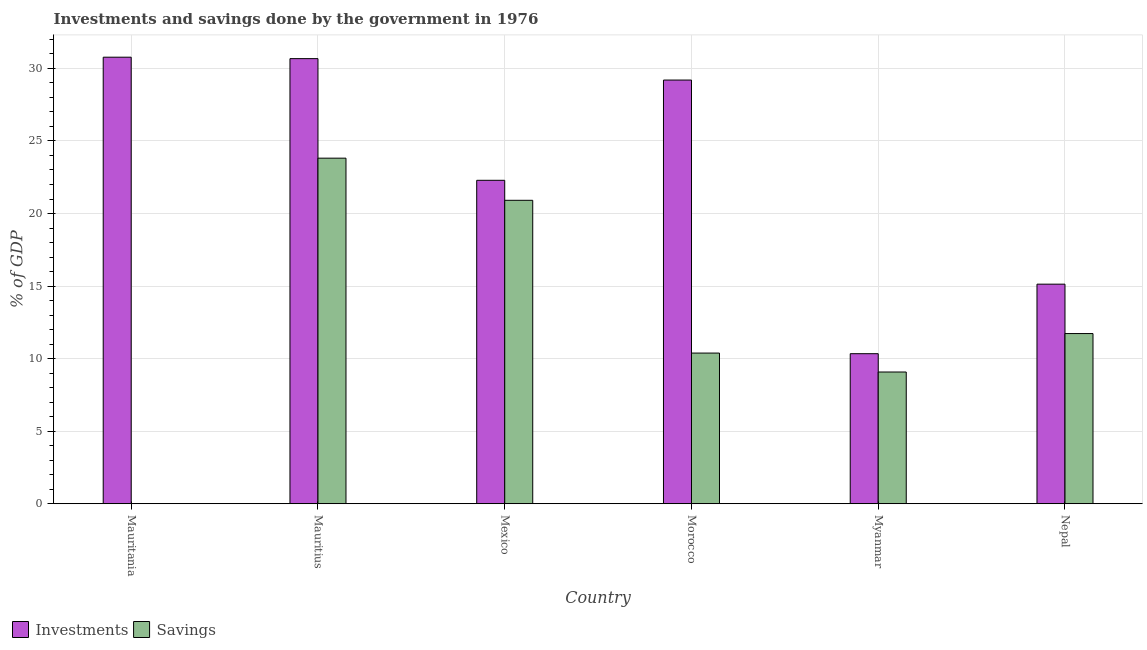Are the number of bars per tick equal to the number of legend labels?
Your response must be concise. No. How many bars are there on the 4th tick from the left?
Your answer should be compact. 2. How many bars are there on the 6th tick from the right?
Make the answer very short. 1. What is the label of the 2nd group of bars from the left?
Your answer should be compact. Mauritius. What is the investments of government in Nepal?
Your answer should be compact. 15.13. Across all countries, what is the maximum investments of government?
Offer a very short reply. 30.77. Across all countries, what is the minimum investments of government?
Offer a terse response. 10.34. In which country was the investments of government maximum?
Ensure brevity in your answer.  Mauritania. What is the total savings of government in the graph?
Your response must be concise. 75.92. What is the difference between the savings of government in Mauritius and that in Mexico?
Provide a succinct answer. 2.9. What is the difference between the investments of government in Myanmar and the savings of government in Morocco?
Ensure brevity in your answer.  -0.04. What is the average savings of government per country?
Give a very brief answer. 12.65. What is the difference between the savings of government and investments of government in Mexico?
Ensure brevity in your answer.  -1.38. In how many countries, is the investments of government greater than 31 %?
Give a very brief answer. 0. What is the ratio of the investments of government in Mauritania to that in Mauritius?
Offer a terse response. 1. Is the investments of government in Mexico less than that in Myanmar?
Make the answer very short. No. Is the difference between the investments of government in Mauritius and Nepal greater than the difference between the savings of government in Mauritius and Nepal?
Provide a short and direct response. Yes. What is the difference between the highest and the second highest investments of government?
Offer a very short reply. 0.1. What is the difference between the highest and the lowest investments of government?
Keep it short and to the point. 20.43. How many bars are there?
Keep it short and to the point. 11. How many countries are there in the graph?
Your answer should be compact. 6. What is the difference between two consecutive major ticks on the Y-axis?
Provide a succinct answer. 5. Are the values on the major ticks of Y-axis written in scientific E-notation?
Give a very brief answer. No. Does the graph contain any zero values?
Offer a terse response. Yes. Does the graph contain grids?
Your answer should be very brief. Yes. Where does the legend appear in the graph?
Provide a short and direct response. Bottom left. How many legend labels are there?
Your answer should be compact. 2. How are the legend labels stacked?
Offer a terse response. Horizontal. What is the title of the graph?
Provide a succinct answer. Investments and savings done by the government in 1976. What is the label or title of the X-axis?
Your answer should be compact. Country. What is the label or title of the Y-axis?
Give a very brief answer. % of GDP. What is the % of GDP in Investments in Mauritania?
Give a very brief answer. 30.77. What is the % of GDP in Investments in Mauritius?
Keep it short and to the point. 30.67. What is the % of GDP in Savings in Mauritius?
Make the answer very short. 23.82. What is the % of GDP in Investments in Mexico?
Make the answer very short. 22.29. What is the % of GDP in Savings in Mexico?
Keep it short and to the point. 20.91. What is the % of GDP of Investments in Morocco?
Offer a terse response. 29.2. What is the % of GDP in Savings in Morocco?
Offer a terse response. 10.38. What is the % of GDP of Investments in Myanmar?
Provide a succinct answer. 10.34. What is the % of GDP in Savings in Myanmar?
Your response must be concise. 9.08. What is the % of GDP in Investments in Nepal?
Ensure brevity in your answer.  15.13. What is the % of GDP of Savings in Nepal?
Your answer should be compact. 11.73. Across all countries, what is the maximum % of GDP in Investments?
Provide a succinct answer. 30.77. Across all countries, what is the maximum % of GDP in Savings?
Your response must be concise. 23.82. Across all countries, what is the minimum % of GDP of Investments?
Your answer should be compact. 10.34. What is the total % of GDP of Investments in the graph?
Ensure brevity in your answer.  138.41. What is the total % of GDP in Savings in the graph?
Offer a very short reply. 75.92. What is the difference between the % of GDP in Investments in Mauritania and that in Mauritius?
Provide a succinct answer. 0.1. What is the difference between the % of GDP in Investments in Mauritania and that in Mexico?
Keep it short and to the point. 8.48. What is the difference between the % of GDP of Investments in Mauritania and that in Morocco?
Keep it short and to the point. 1.58. What is the difference between the % of GDP in Investments in Mauritania and that in Myanmar?
Offer a very short reply. 20.43. What is the difference between the % of GDP in Investments in Mauritania and that in Nepal?
Ensure brevity in your answer.  15.64. What is the difference between the % of GDP of Investments in Mauritius and that in Mexico?
Your answer should be compact. 8.39. What is the difference between the % of GDP of Savings in Mauritius and that in Mexico?
Offer a very short reply. 2.9. What is the difference between the % of GDP of Investments in Mauritius and that in Morocco?
Your answer should be very brief. 1.48. What is the difference between the % of GDP in Savings in Mauritius and that in Morocco?
Make the answer very short. 13.43. What is the difference between the % of GDP of Investments in Mauritius and that in Myanmar?
Make the answer very short. 20.33. What is the difference between the % of GDP of Savings in Mauritius and that in Myanmar?
Keep it short and to the point. 14.74. What is the difference between the % of GDP of Investments in Mauritius and that in Nepal?
Ensure brevity in your answer.  15.54. What is the difference between the % of GDP of Savings in Mauritius and that in Nepal?
Provide a short and direct response. 12.09. What is the difference between the % of GDP of Investments in Mexico and that in Morocco?
Offer a very short reply. -6.91. What is the difference between the % of GDP in Savings in Mexico and that in Morocco?
Offer a very short reply. 10.53. What is the difference between the % of GDP in Investments in Mexico and that in Myanmar?
Offer a terse response. 11.95. What is the difference between the % of GDP in Savings in Mexico and that in Myanmar?
Give a very brief answer. 11.83. What is the difference between the % of GDP of Investments in Mexico and that in Nepal?
Your answer should be compact. 7.16. What is the difference between the % of GDP of Savings in Mexico and that in Nepal?
Ensure brevity in your answer.  9.18. What is the difference between the % of GDP of Investments in Morocco and that in Myanmar?
Offer a terse response. 18.86. What is the difference between the % of GDP of Savings in Morocco and that in Myanmar?
Keep it short and to the point. 1.3. What is the difference between the % of GDP in Investments in Morocco and that in Nepal?
Give a very brief answer. 14.07. What is the difference between the % of GDP of Savings in Morocco and that in Nepal?
Your response must be concise. -1.34. What is the difference between the % of GDP of Investments in Myanmar and that in Nepal?
Provide a short and direct response. -4.79. What is the difference between the % of GDP in Savings in Myanmar and that in Nepal?
Your answer should be very brief. -2.65. What is the difference between the % of GDP in Investments in Mauritania and the % of GDP in Savings in Mauritius?
Offer a terse response. 6.96. What is the difference between the % of GDP in Investments in Mauritania and the % of GDP in Savings in Mexico?
Provide a succinct answer. 9.86. What is the difference between the % of GDP in Investments in Mauritania and the % of GDP in Savings in Morocco?
Provide a succinct answer. 20.39. What is the difference between the % of GDP in Investments in Mauritania and the % of GDP in Savings in Myanmar?
Give a very brief answer. 21.69. What is the difference between the % of GDP of Investments in Mauritania and the % of GDP of Savings in Nepal?
Provide a succinct answer. 19.04. What is the difference between the % of GDP of Investments in Mauritius and the % of GDP of Savings in Mexico?
Give a very brief answer. 9.76. What is the difference between the % of GDP in Investments in Mauritius and the % of GDP in Savings in Morocco?
Provide a succinct answer. 20.29. What is the difference between the % of GDP in Investments in Mauritius and the % of GDP in Savings in Myanmar?
Your answer should be very brief. 21.6. What is the difference between the % of GDP in Investments in Mauritius and the % of GDP in Savings in Nepal?
Offer a very short reply. 18.95. What is the difference between the % of GDP of Investments in Mexico and the % of GDP of Savings in Morocco?
Your response must be concise. 11.91. What is the difference between the % of GDP in Investments in Mexico and the % of GDP in Savings in Myanmar?
Your answer should be compact. 13.21. What is the difference between the % of GDP in Investments in Mexico and the % of GDP in Savings in Nepal?
Provide a short and direct response. 10.56. What is the difference between the % of GDP of Investments in Morocco and the % of GDP of Savings in Myanmar?
Keep it short and to the point. 20.12. What is the difference between the % of GDP in Investments in Morocco and the % of GDP in Savings in Nepal?
Provide a succinct answer. 17.47. What is the difference between the % of GDP of Investments in Myanmar and the % of GDP of Savings in Nepal?
Keep it short and to the point. -1.39. What is the average % of GDP of Investments per country?
Ensure brevity in your answer.  23.07. What is the average % of GDP in Savings per country?
Ensure brevity in your answer.  12.65. What is the difference between the % of GDP in Investments and % of GDP in Savings in Mauritius?
Provide a short and direct response. 6.86. What is the difference between the % of GDP in Investments and % of GDP in Savings in Mexico?
Your response must be concise. 1.38. What is the difference between the % of GDP of Investments and % of GDP of Savings in Morocco?
Give a very brief answer. 18.81. What is the difference between the % of GDP in Investments and % of GDP in Savings in Myanmar?
Offer a terse response. 1.26. What is the difference between the % of GDP in Investments and % of GDP in Savings in Nepal?
Your answer should be compact. 3.4. What is the ratio of the % of GDP of Investments in Mauritania to that in Mauritius?
Keep it short and to the point. 1. What is the ratio of the % of GDP in Investments in Mauritania to that in Mexico?
Provide a succinct answer. 1.38. What is the ratio of the % of GDP of Investments in Mauritania to that in Morocco?
Provide a succinct answer. 1.05. What is the ratio of the % of GDP of Investments in Mauritania to that in Myanmar?
Your answer should be very brief. 2.98. What is the ratio of the % of GDP in Investments in Mauritania to that in Nepal?
Make the answer very short. 2.03. What is the ratio of the % of GDP in Investments in Mauritius to that in Mexico?
Make the answer very short. 1.38. What is the ratio of the % of GDP of Savings in Mauritius to that in Mexico?
Offer a terse response. 1.14. What is the ratio of the % of GDP in Investments in Mauritius to that in Morocco?
Your answer should be very brief. 1.05. What is the ratio of the % of GDP in Savings in Mauritius to that in Morocco?
Make the answer very short. 2.29. What is the ratio of the % of GDP of Investments in Mauritius to that in Myanmar?
Make the answer very short. 2.97. What is the ratio of the % of GDP of Savings in Mauritius to that in Myanmar?
Ensure brevity in your answer.  2.62. What is the ratio of the % of GDP of Investments in Mauritius to that in Nepal?
Provide a succinct answer. 2.03. What is the ratio of the % of GDP in Savings in Mauritius to that in Nepal?
Offer a terse response. 2.03. What is the ratio of the % of GDP of Investments in Mexico to that in Morocco?
Make the answer very short. 0.76. What is the ratio of the % of GDP in Savings in Mexico to that in Morocco?
Ensure brevity in your answer.  2.01. What is the ratio of the % of GDP of Investments in Mexico to that in Myanmar?
Your answer should be very brief. 2.16. What is the ratio of the % of GDP in Savings in Mexico to that in Myanmar?
Keep it short and to the point. 2.3. What is the ratio of the % of GDP of Investments in Mexico to that in Nepal?
Offer a terse response. 1.47. What is the ratio of the % of GDP in Savings in Mexico to that in Nepal?
Provide a short and direct response. 1.78. What is the ratio of the % of GDP of Investments in Morocco to that in Myanmar?
Your response must be concise. 2.82. What is the ratio of the % of GDP in Savings in Morocco to that in Myanmar?
Make the answer very short. 1.14. What is the ratio of the % of GDP in Investments in Morocco to that in Nepal?
Your answer should be compact. 1.93. What is the ratio of the % of GDP in Savings in Morocco to that in Nepal?
Offer a very short reply. 0.89. What is the ratio of the % of GDP of Investments in Myanmar to that in Nepal?
Your answer should be very brief. 0.68. What is the ratio of the % of GDP of Savings in Myanmar to that in Nepal?
Ensure brevity in your answer.  0.77. What is the difference between the highest and the second highest % of GDP in Investments?
Provide a short and direct response. 0.1. What is the difference between the highest and the second highest % of GDP in Savings?
Your answer should be very brief. 2.9. What is the difference between the highest and the lowest % of GDP in Investments?
Ensure brevity in your answer.  20.43. What is the difference between the highest and the lowest % of GDP in Savings?
Offer a terse response. 23.82. 